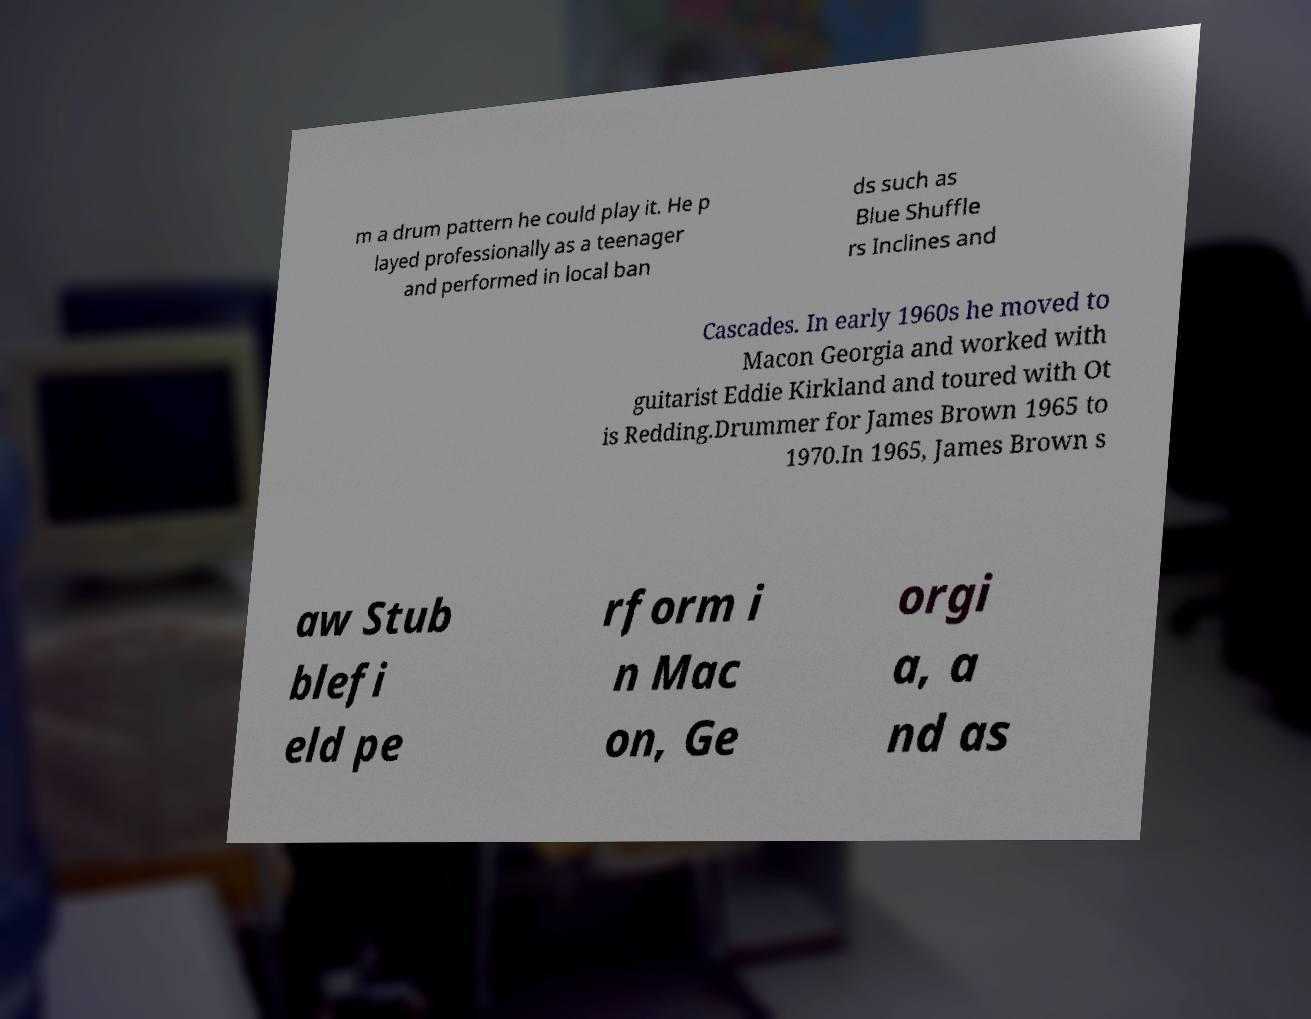For documentation purposes, I need the text within this image transcribed. Could you provide that? m a drum pattern he could play it. He p layed professionally as a teenager and performed in local ban ds such as Blue Shuffle rs Inclines and Cascades. In early 1960s he moved to Macon Georgia and worked with guitarist Eddie Kirkland and toured with Ot is Redding.Drummer for James Brown 1965 to 1970.In 1965, James Brown s aw Stub blefi eld pe rform i n Mac on, Ge orgi a, a nd as 